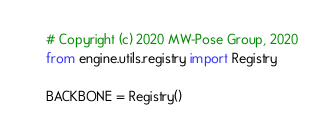<code> <loc_0><loc_0><loc_500><loc_500><_Python_># Copyright (c) 2020 MW-Pose Group, 2020
from engine.utils.registry import Registry

BACKBONE = Registry()
</code> 